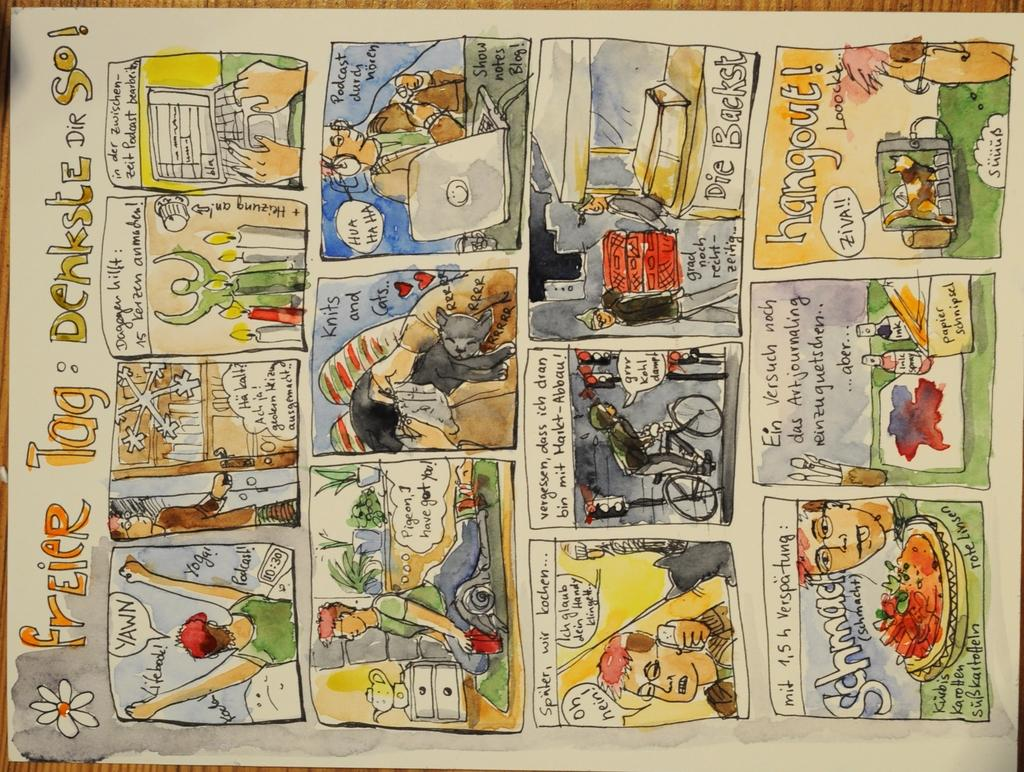Provide a one-sentence caption for the provided image. A comic strip from a newspaper with the title Freier Tag Denksle Dir So.. 